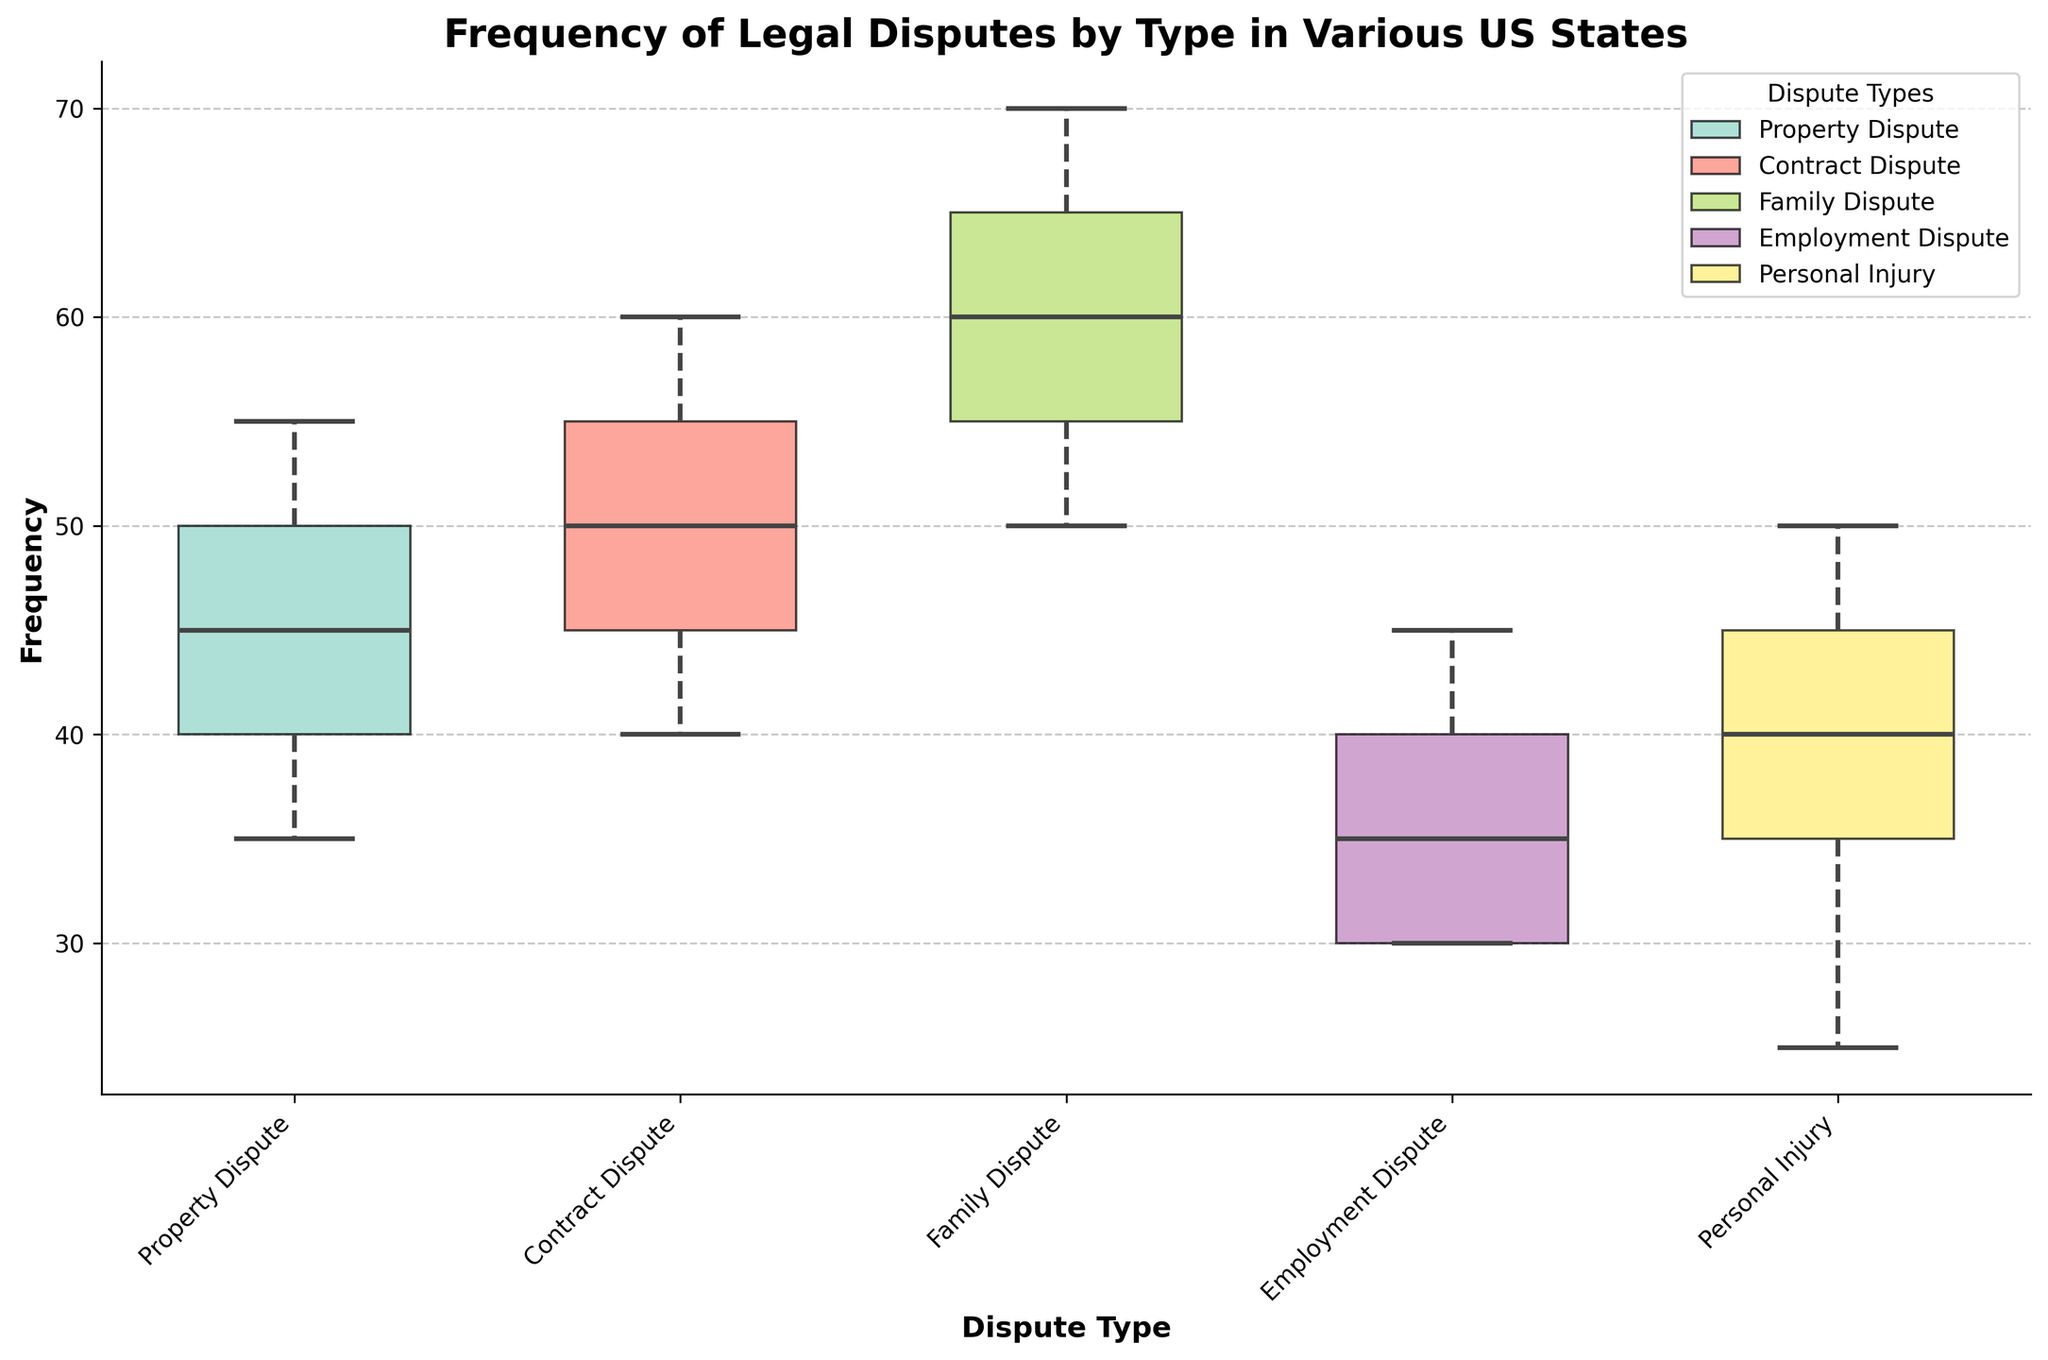What is the title of the plot? The title is usually displayed at the top of the plot to give an overview of what the plot represents. Here, the title is visible at the top center of the plot.
Answer: Frequency of Legal Disputes by Type in Various US States Which dispute type has the highest median frequency? To determine the highest median frequency, look at the line in the middle of each box plot, which represents the median. Compare the position of these lines across all box plots.
Answer: Family Dispute How many dispute types are represented in the plot? Count the total unique categories indicated along the x-axis, which are represented in the box plots and the legend.
Answer: 5 Which state appears to have the highest frequency of Contract Disputes? Observing the box plots, cross-reference the Contract Dispute box plot with the highest median line within Contract Disputes. The states themselves are not marked explicitly on the plot, so this might need a cross-reference with the data provided.
Answer: New York How does the frequency of Property Disputes compare between California and Texas? Compare the heights of the Property Dispute box plots for California and Texas. Since the widths indicate the number of data points, check the overall spread and the positioning of the medians.
Answer: Texas is higher What is the range (difference between the maximum and minimum) of Family Disputes in Florida? Look at the Family Dispute box plot for Florida and assess the top whisker representing the maximum value and the bottom whisker representing the minimum value, then subtract the minimum from the maximum.
Answer: 70 - 50 = 20 Which dispute type has the largest interquartile range (IQR) in California? The IQR is represented by the height of the box. Compare the heights of the boxes within California's disputes; the tallest box provides the largest IQR.
Answer: Family Dispute Which dispute type appears to be least frequent in Illinois? Identify the box plot for Illinois that has the lowest median line. This will indicate the least frequent dispute type in Illinois.
Answer: Personal Injury Are there any states where the frequency of Employment Disputes exceeds 50? Review the Employment Dispute box plots to see if any of the data points or whiskers exceed the value of 50.
Answer: No Compare the variability (spread) of Personal Injury disputes across all states. Examine the width of the boxes and lengths of the whiskers for the Personal Injury disputes. Greater box height and whisker length indicate higher variability.
Answer: Texas has the most variability in Personal Injury disputes 